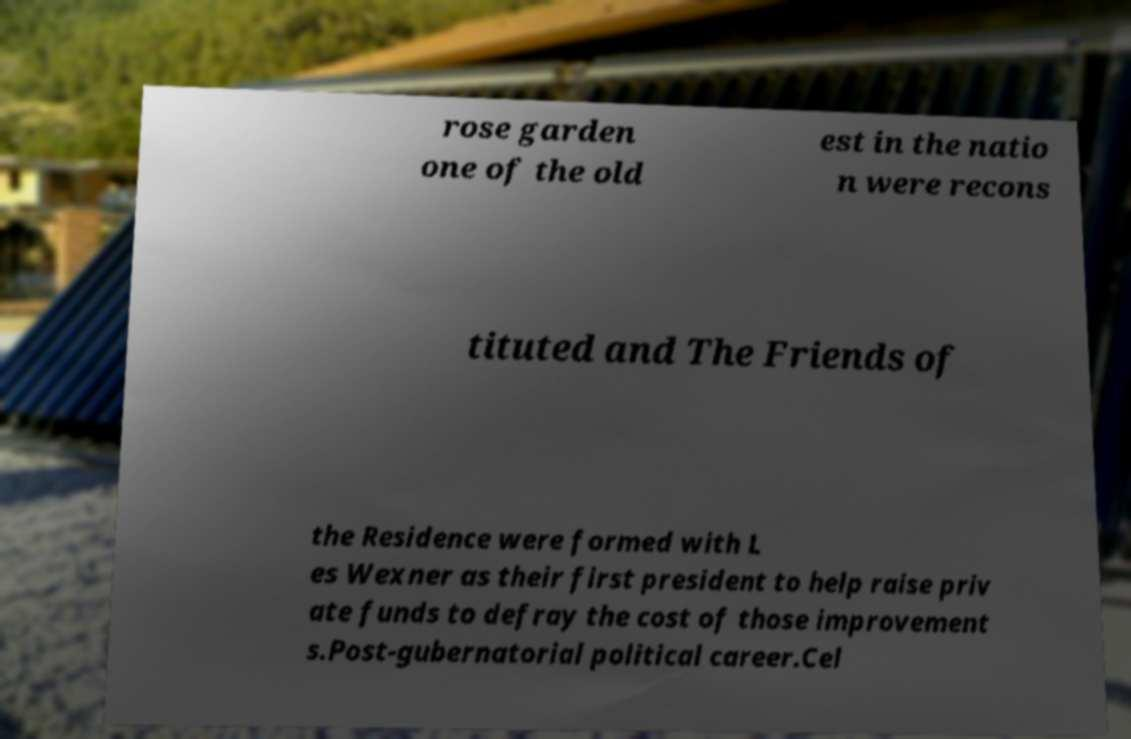Please identify and transcribe the text found in this image. rose garden one of the old est in the natio n were recons tituted and The Friends of the Residence were formed with L es Wexner as their first president to help raise priv ate funds to defray the cost of those improvement s.Post-gubernatorial political career.Cel 